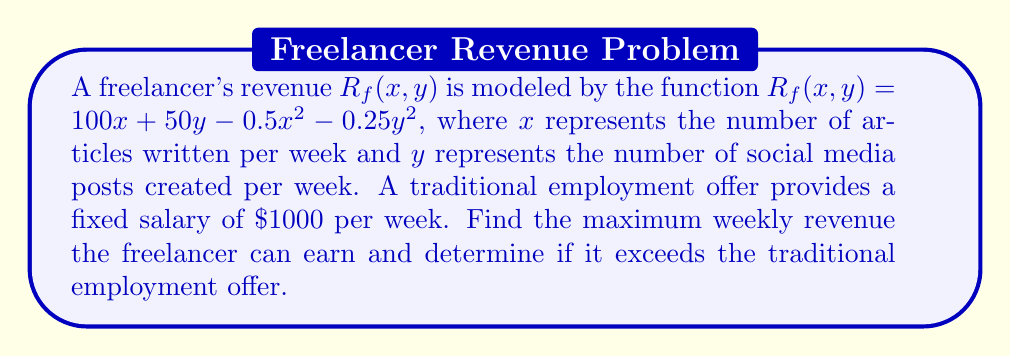Can you answer this question? To find the maximum revenue for the freelancer, we need to find the critical points of the revenue function $R_f(x, y)$ and evaluate them.

Step 1: Calculate the partial derivatives of $R_f(x, y)$:
$$\frac{\partial R_f}{\partial x} = 100 - x$$
$$\frac{\partial R_f}{\partial y} = 50 - 0.5y$$

Step 2: Set the partial derivatives equal to zero and solve for $x$ and $y$:
$$100 - x = 0 \implies x = 100$$
$$50 - 0.5y = 0 \implies y = 100$$

Step 3: Verify that this critical point $(100, 100)$ is a maximum by checking the second partial derivatives:
$$\frac{\partial^2 R_f}{\partial x^2} = -1 < 0$$
$$\frac{\partial^2 R_f}{\partial y^2} = -0.5 < 0$$

Since both second partial derivatives are negative, the critical point is a local maximum.

Step 4: Calculate the maximum revenue by evaluating $R_f(100, 100)$:
$$R_f(100, 100) = 100(100) + 50(100) - 0.5(100)^2 - 0.25(100)^2$$
$$= 10000 + 5000 - 5000 - 2500 = 7500$$

Step 5: Compare the maximum freelance revenue to the traditional employment offer:
$7500 > 1000$, so the freelancer's maximum revenue exceeds the traditional employment offer.
Answer: $7500 per week, which exceeds the traditional offer 